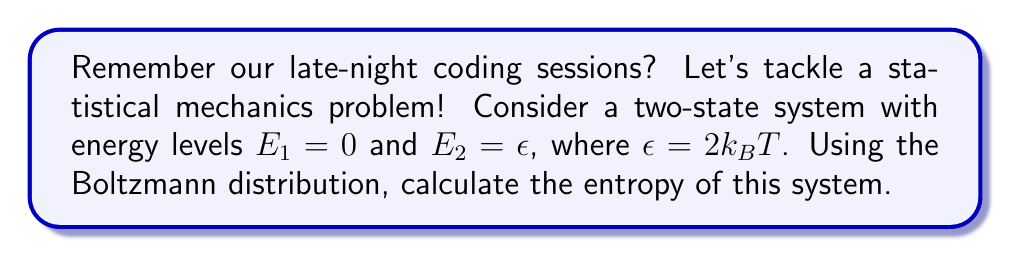Can you answer this question? Let's approach this step-by-step:

1) The Boltzmann distribution gives the probability of a system being in a state with energy $E_i$:

   $$ p_i = \frac{e^{-E_i/k_BT}}{Z} $$

   where $Z$ is the partition function.

2) For our two-state system, the partition function is:

   $$ Z = e^{-E_1/k_BT} + e^{-E_2/k_BT} = 1 + e^{-\epsilon/k_BT} $$

3) Given that $\epsilon = 2k_BT$, we can simplify:

   $$ Z = 1 + e^{-2} $$

4) Now, let's calculate the probabilities:

   $$ p_1 = \frac{1}{1 + e^{-2}} \quad \text{and} \quad p_2 = \frac{e^{-2}}{1 + e^{-2}} $$

5) The entropy is given by the formula:

   $$ S = -k_B \sum_i p_i \ln p_i $$

6) Substituting our probabilities:

   $$ S = -k_B \left( \frac{1}{1 + e^{-2}} \ln\left(\frac{1}{1 + e^{-2}}\right) + \frac{e^{-2}}{1 + e^{-2}} \ln\left(\frac{e^{-2}}{1 + e^{-2}}\right) \right) $$

7) Simplifying:

   $$ S = k_B \left( \ln(1 + e^{-2}) + \frac{2e^{-2}}{1 + e^{-2}} \right) $$

This is our final expression for the entropy of the system.
Answer: $S = k_B \left( \ln(1 + e^{-2}) + \frac{2e^{-2}}{1 + e^{-2}} \right)$ 